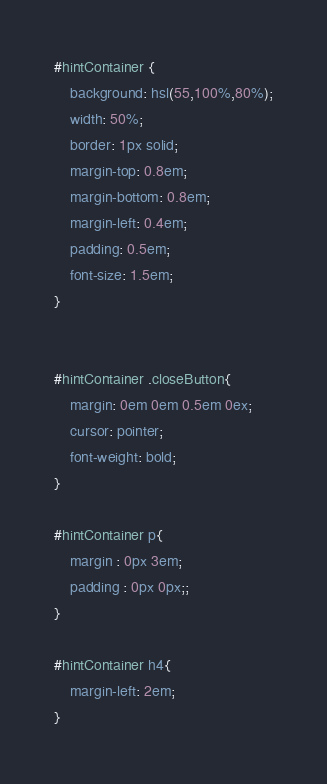<code> <loc_0><loc_0><loc_500><loc_500><_CSS_>
#hintContainer {
    background: hsl(55,100%,80%);
    width: 50%;
    border: 1px solid;
    margin-top: 0.8em;
    margin-bottom: 0.8em;
    margin-left: 0.4em;
    padding: 0.5em;
    font-size: 1.5em;
}


#hintContainer .closeButton{
    margin: 0em 0em 0.5em 0ex;
    cursor: pointer;
    font-weight: bold;
}

#hintContainer p{
    margin : 0px 3em;
    padding : 0px 0px;;
}

#hintContainer h4{
    margin-left: 2em;
}
</code> 